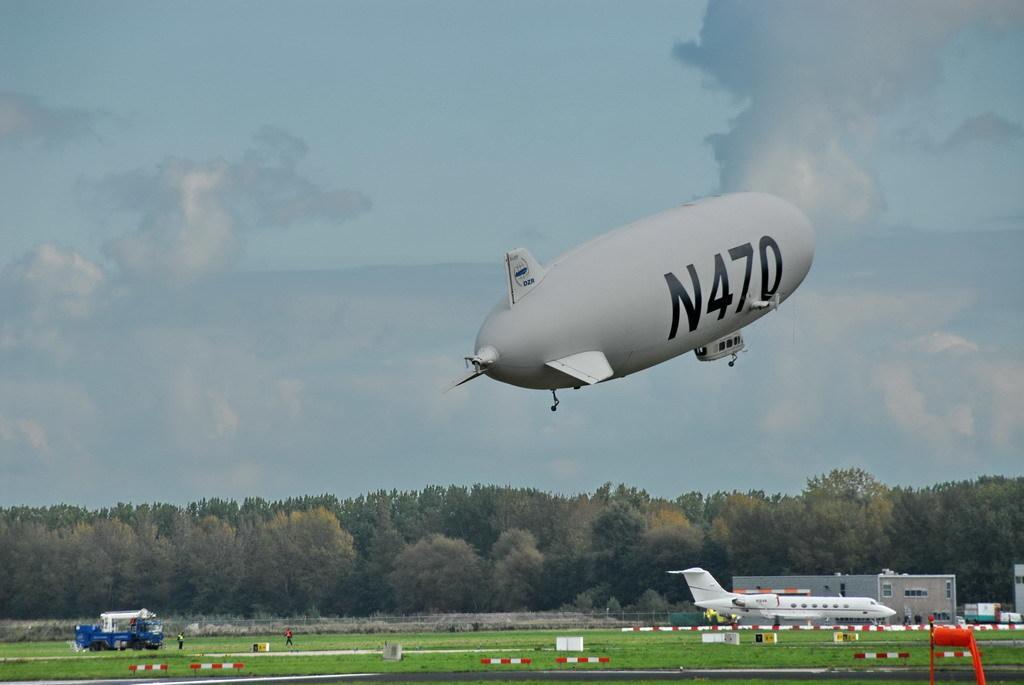Describe this image in one or two sentences. In this image I can see at the bottom there is an aeroplane in white color. On the left side there is a vehicle in blue color. In the middle there are trees, at the top there is an aeroplane in grey color. At the top it is the sky. 